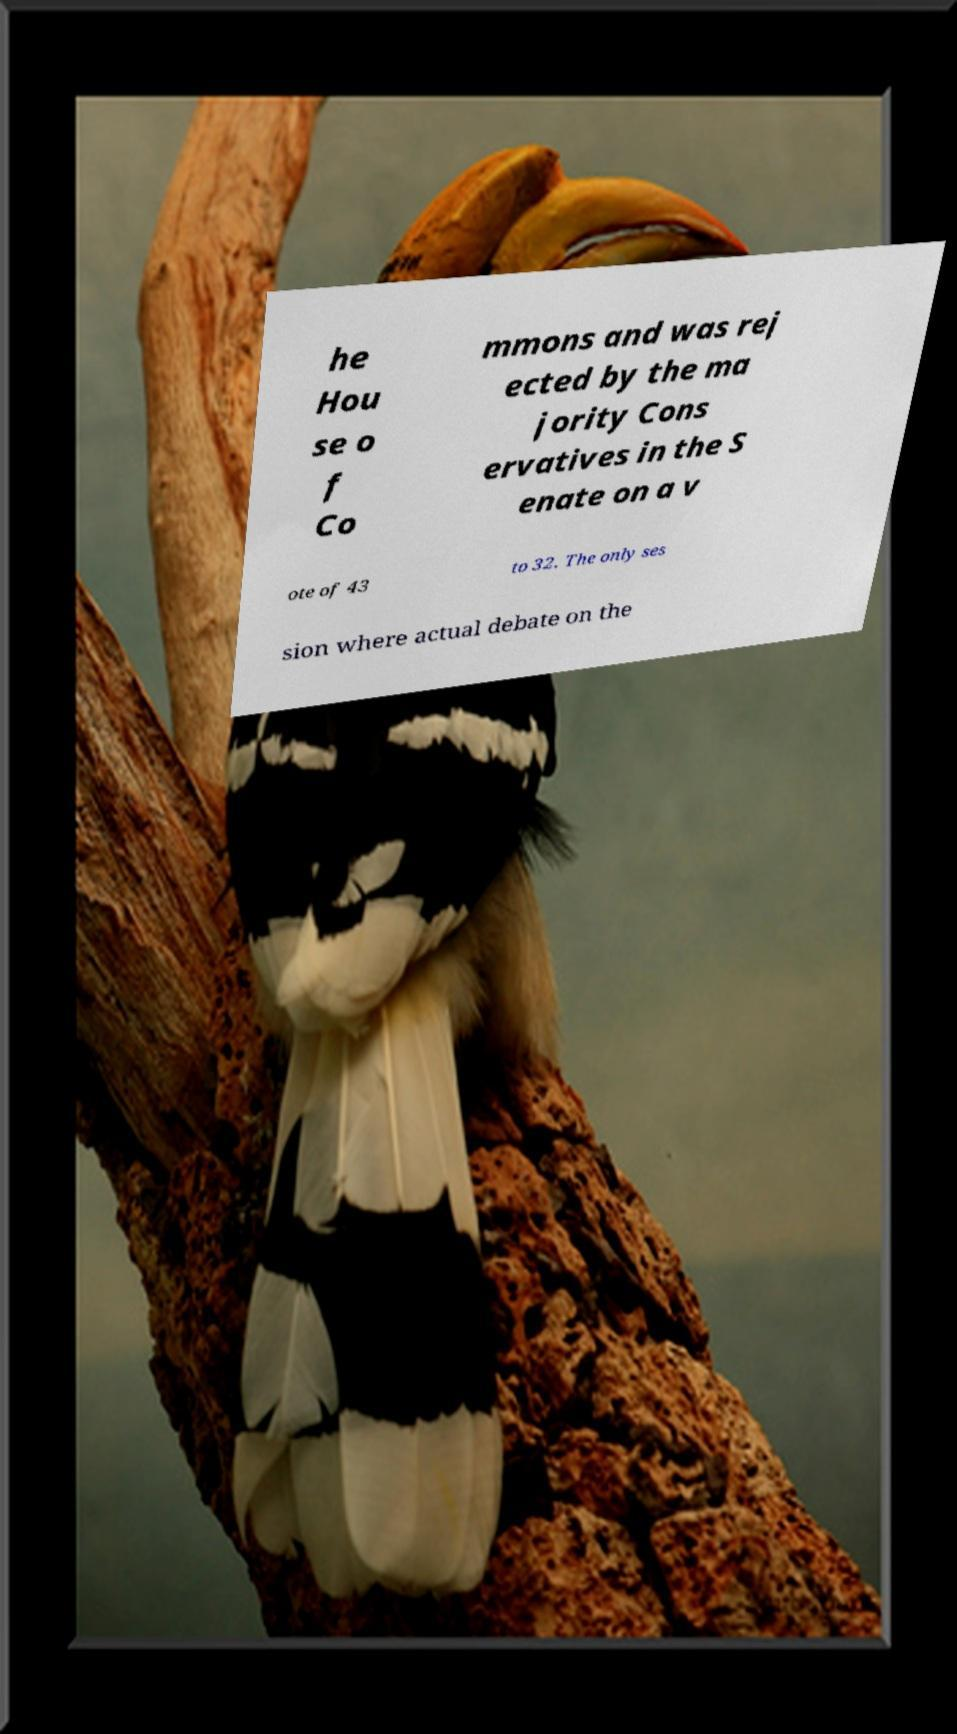Please identify and transcribe the text found in this image. he Hou se o f Co mmons and was rej ected by the ma jority Cons ervatives in the S enate on a v ote of 43 to 32. The only ses sion where actual debate on the 